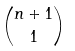<formula> <loc_0><loc_0><loc_500><loc_500>\binom { n + 1 } { 1 }</formula> 